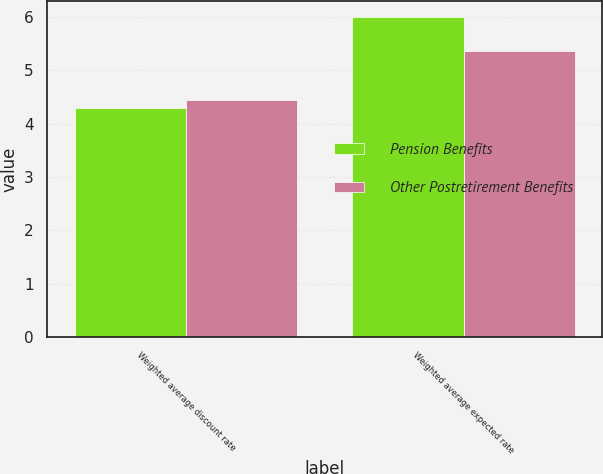Convert chart. <chart><loc_0><loc_0><loc_500><loc_500><stacked_bar_chart><ecel><fcel>Weighted average discount rate<fcel>Weighted average expected rate<nl><fcel>Pension Benefits<fcel>4.3<fcel>6<nl><fcel>Other Postretirement Benefits<fcel>4.45<fcel>5.36<nl></chart> 